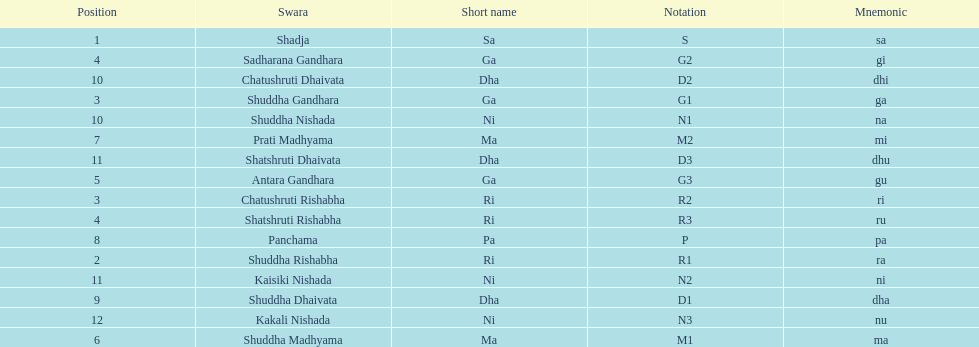Find the 9th position swara. what is its short name? Dha. 